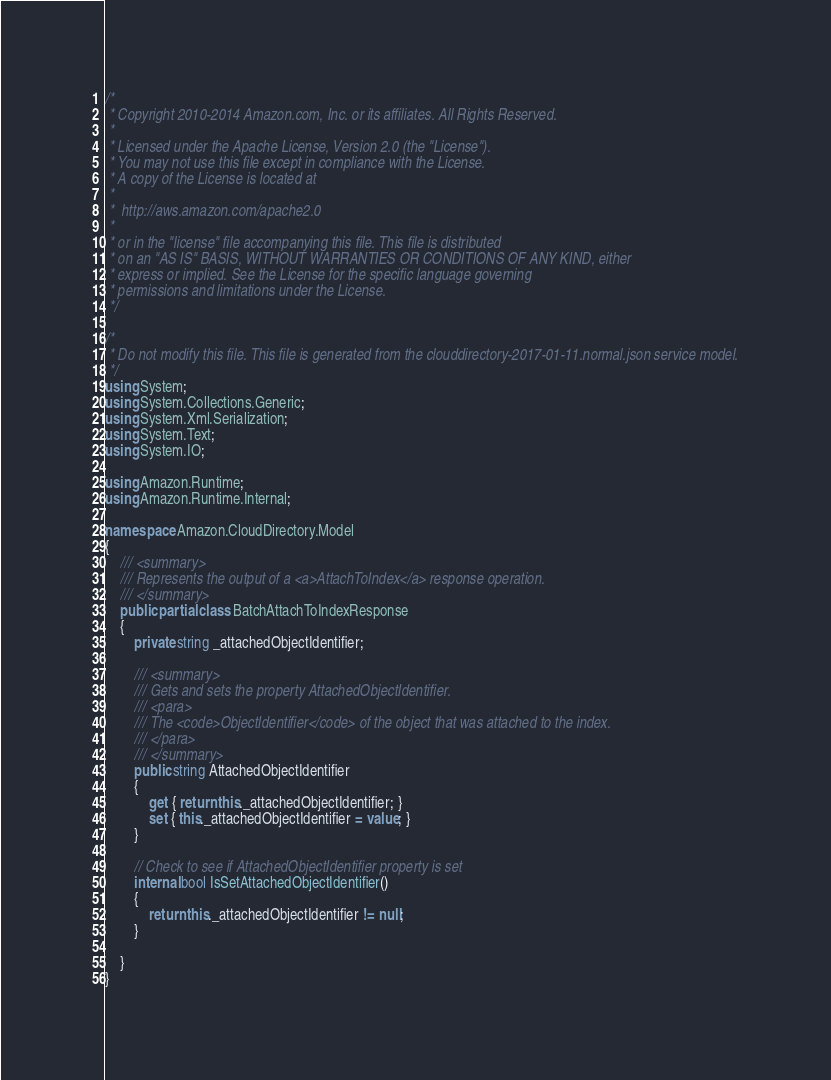<code> <loc_0><loc_0><loc_500><loc_500><_C#_>/*
 * Copyright 2010-2014 Amazon.com, Inc. or its affiliates. All Rights Reserved.
 * 
 * Licensed under the Apache License, Version 2.0 (the "License").
 * You may not use this file except in compliance with the License.
 * A copy of the License is located at
 * 
 *  http://aws.amazon.com/apache2.0
 * 
 * or in the "license" file accompanying this file. This file is distributed
 * on an "AS IS" BASIS, WITHOUT WARRANTIES OR CONDITIONS OF ANY KIND, either
 * express or implied. See the License for the specific language governing
 * permissions and limitations under the License.
 */

/*
 * Do not modify this file. This file is generated from the clouddirectory-2017-01-11.normal.json service model.
 */
using System;
using System.Collections.Generic;
using System.Xml.Serialization;
using System.Text;
using System.IO;

using Amazon.Runtime;
using Amazon.Runtime.Internal;

namespace Amazon.CloudDirectory.Model
{
    /// <summary>
    /// Represents the output of a <a>AttachToIndex</a> response operation.
    /// </summary>
    public partial class BatchAttachToIndexResponse
    {
        private string _attachedObjectIdentifier;

        /// <summary>
        /// Gets and sets the property AttachedObjectIdentifier. 
        /// <para>
        /// The <code>ObjectIdentifier</code> of the object that was attached to the index.
        /// </para>
        /// </summary>
        public string AttachedObjectIdentifier
        {
            get { return this._attachedObjectIdentifier; }
            set { this._attachedObjectIdentifier = value; }
        }

        // Check to see if AttachedObjectIdentifier property is set
        internal bool IsSetAttachedObjectIdentifier()
        {
            return this._attachedObjectIdentifier != null;
        }

    }
}</code> 